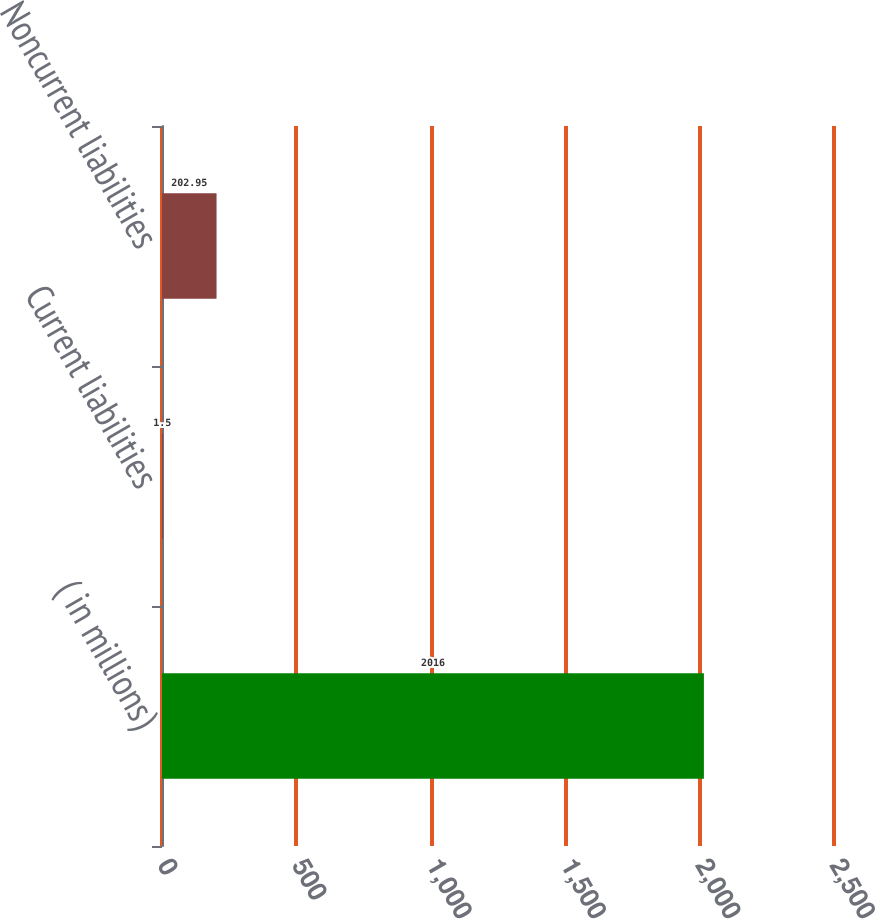Convert chart to OTSL. <chart><loc_0><loc_0><loc_500><loc_500><bar_chart><fcel>( in millions)<fcel>Current liabilities<fcel>Noncurrent liabilities<nl><fcel>2016<fcel>1.5<fcel>202.95<nl></chart> 